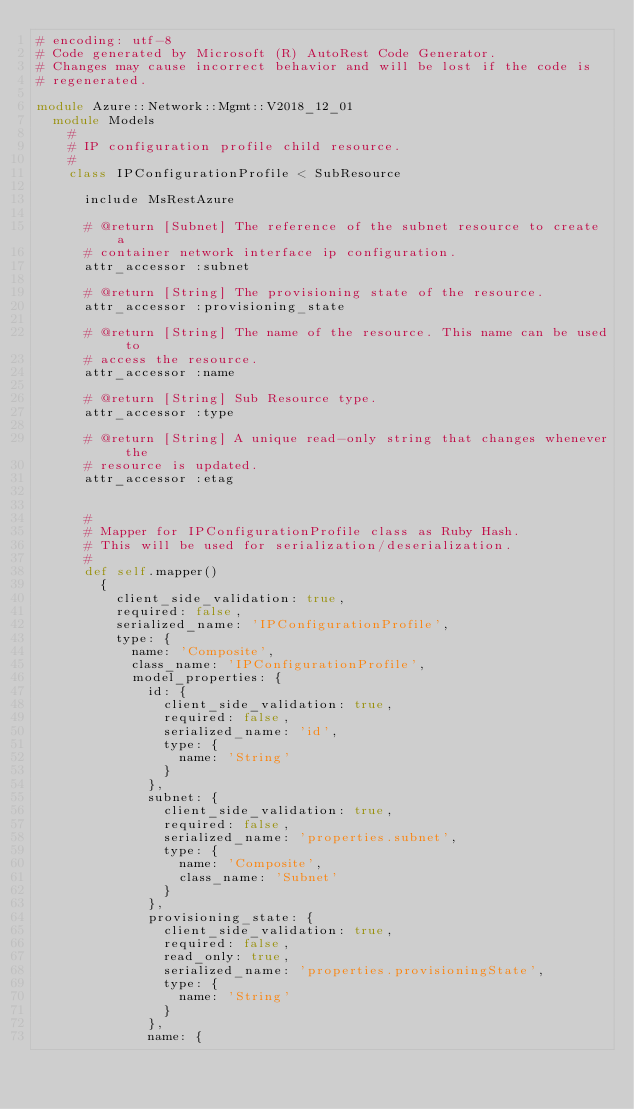Convert code to text. <code><loc_0><loc_0><loc_500><loc_500><_Ruby_># encoding: utf-8
# Code generated by Microsoft (R) AutoRest Code Generator.
# Changes may cause incorrect behavior and will be lost if the code is
# regenerated.

module Azure::Network::Mgmt::V2018_12_01
  module Models
    #
    # IP configuration profile child resource.
    #
    class IPConfigurationProfile < SubResource

      include MsRestAzure

      # @return [Subnet] The reference of the subnet resource to create a
      # container network interface ip configuration.
      attr_accessor :subnet

      # @return [String] The provisioning state of the resource.
      attr_accessor :provisioning_state

      # @return [String] The name of the resource. This name can be used to
      # access the resource.
      attr_accessor :name

      # @return [String] Sub Resource type.
      attr_accessor :type

      # @return [String] A unique read-only string that changes whenever the
      # resource is updated.
      attr_accessor :etag


      #
      # Mapper for IPConfigurationProfile class as Ruby Hash.
      # This will be used for serialization/deserialization.
      #
      def self.mapper()
        {
          client_side_validation: true,
          required: false,
          serialized_name: 'IPConfigurationProfile',
          type: {
            name: 'Composite',
            class_name: 'IPConfigurationProfile',
            model_properties: {
              id: {
                client_side_validation: true,
                required: false,
                serialized_name: 'id',
                type: {
                  name: 'String'
                }
              },
              subnet: {
                client_side_validation: true,
                required: false,
                serialized_name: 'properties.subnet',
                type: {
                  name: 'Composite',
                  class_name: 'Subnet'
                }
              },
              provisioning_state: {
                client_side_validation: true,
                required: false,
                read_only: true,
                serialized_name: 'properties.provisioningState',
                type: {
                  name: 'String'
                }
              },
              name: {</code> 